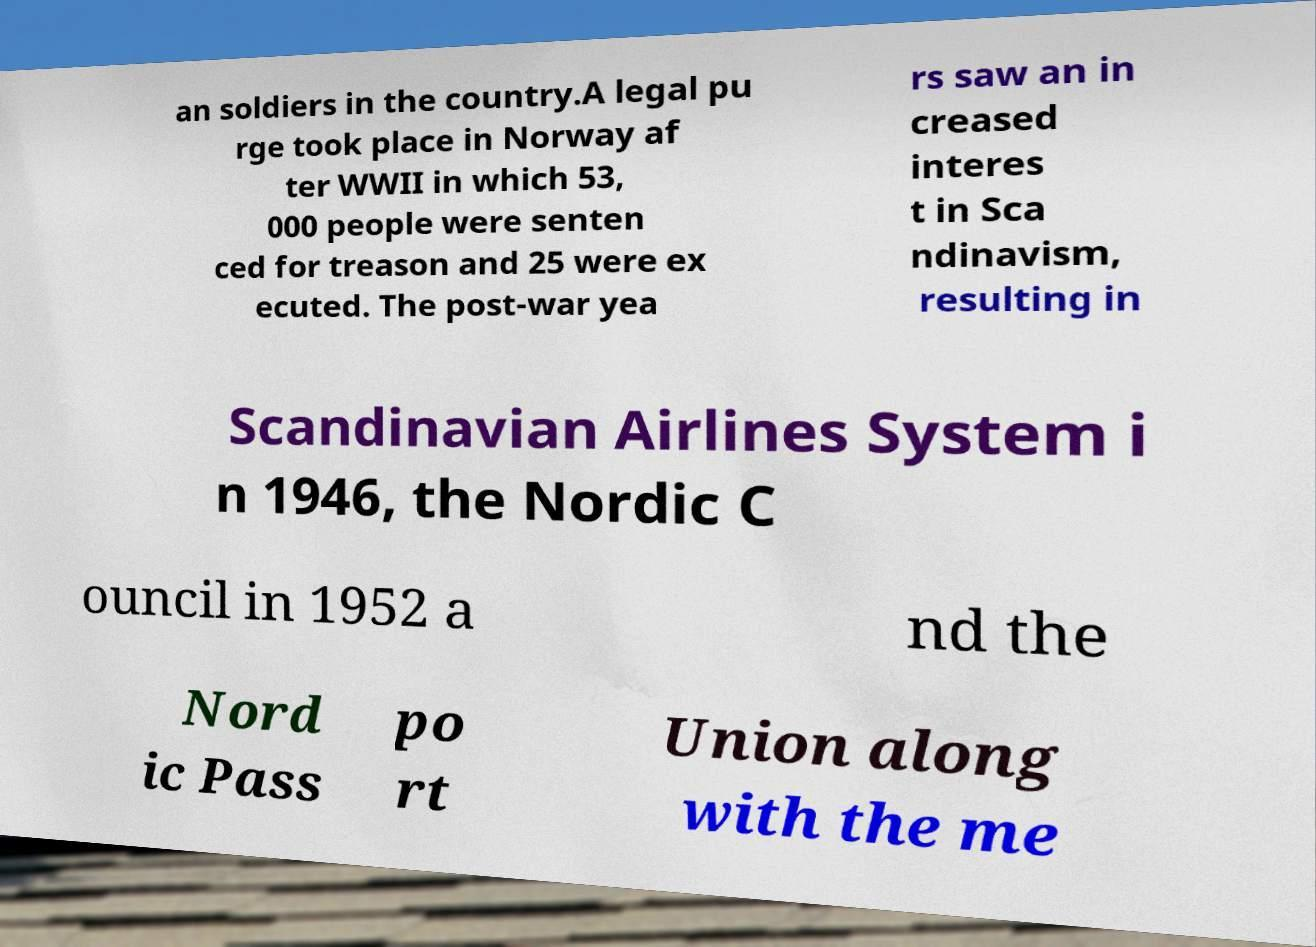For documentation purposes, I need the text within this image transcribed. Could you provide that? an soldiers in the country.A legal pu rge took place in Norway af ter WWII in which 53, 000 people were senten ced for treason and 25 were ex ecuted. The post-war yea rs saw an in creased interes t in Sca ndinavism, resulting in Scandinavian Airlines System i n 1946, the Nordic C ouncil in 1952 a nd the Nord ic Pass po rt Union along with the me 